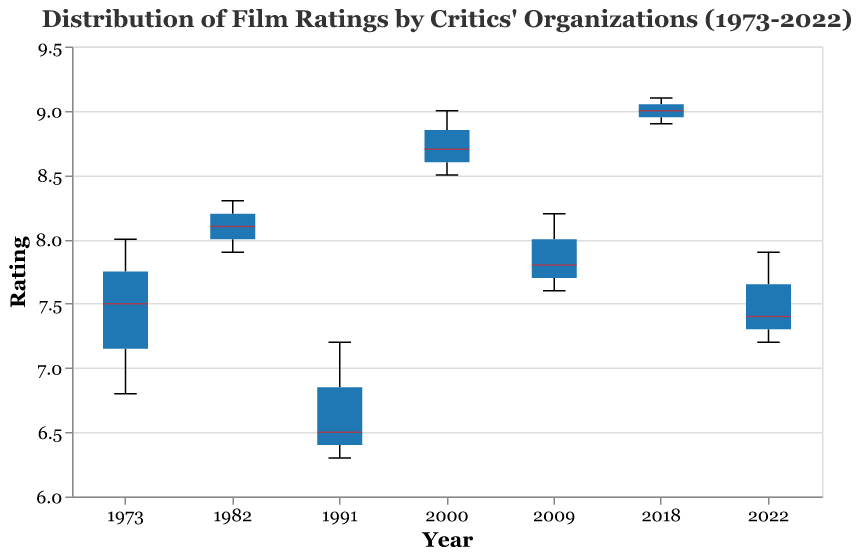What's the median rating for the New York Times in 2018? To find the median rating for the New York Times in 2018, look for the boxplot specific to the New York Times in the year 2018 and identify the line that represents the median within that box.
Answer: 9.0 How does the highest rating in 2000 compare to the lowest rating in 1991? First, identify the highest rating in 2000, which is 9.0 by the National Board of Review. Then, find the lowest rating in 1991, which is 6.3 by the Los Angeles Times. Compare these two values.
Answer: 9.0 is higher than 6.3 What's the range of ratings given by the Los Angeles Times in 2022? To find the range, subtract the minimum rating from the maximum rating within the Los Angeles Times' boxplot for 2022. The ratings for this organization range from 7.2 to 7.2.
Answer: 0.0 In which year did the National Board of Review give the lowest median rating? To determine this, examine the medians of the National Board of Review's ratings across all years. The median is lowest in the year that has the smallest median line within the boxplot.
Answer: 1991 What is the interquartile range (IQR) of ratings for the New York Times in 1973? To find the IQR, identify the first quartile (Q1) and the third quartile (Q3) for the New York Times in 1973. The IQR is the difference between Q3 and Q1.
Answer: Cannot be determined from the figure alone (specific quartile values not provided) Comparing the valuation from New York Times, which year has the highest median rating? To find which year has the highest median rating from New York Times, look at all the median lines in the New York Times boxplots and identify the highest one.
Answer: 2018 How have the ratings given by the National Board of Review changed from 2000 to 2022? First, find the ratings given by the National Board of Review in 2000 and in 2022. In 2000, it is 9.0, and in 2022, it is 7.9. Then calculate the difference.
Answer: Decreased by 1.1 points Which critic organization showed the most variability in ratings for the year 1982? Examine the boxplots for 1982 and compare the interquartile ranges (height of the boxes) and range (total spread from minimum to maximum) among the three critic organizations. The one with the tallest box or the largest total range shows the most variability.
Answer: Los Angeles Times Do the ratings generally increase, decrease, or stay the same for the National Board of Review from 1973 to 2022? To answer this, look at the median ratings for the National Board of Review over the years from 1973 to 2022. Identify any trends based on the median lines within each boxplot.
Answer: No obvious trend (values vary over the years) 